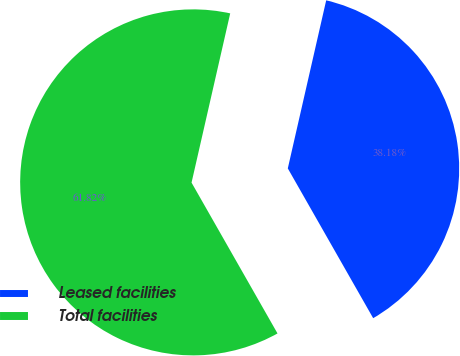Convert chart. <chart><loc_0><loc_0><loc_500><loc_500><pie_chart><fcel>Leased facilities<fcel>Total facilities<nl><fcel>38.18%<fcel>61.82%<nl></chart> 